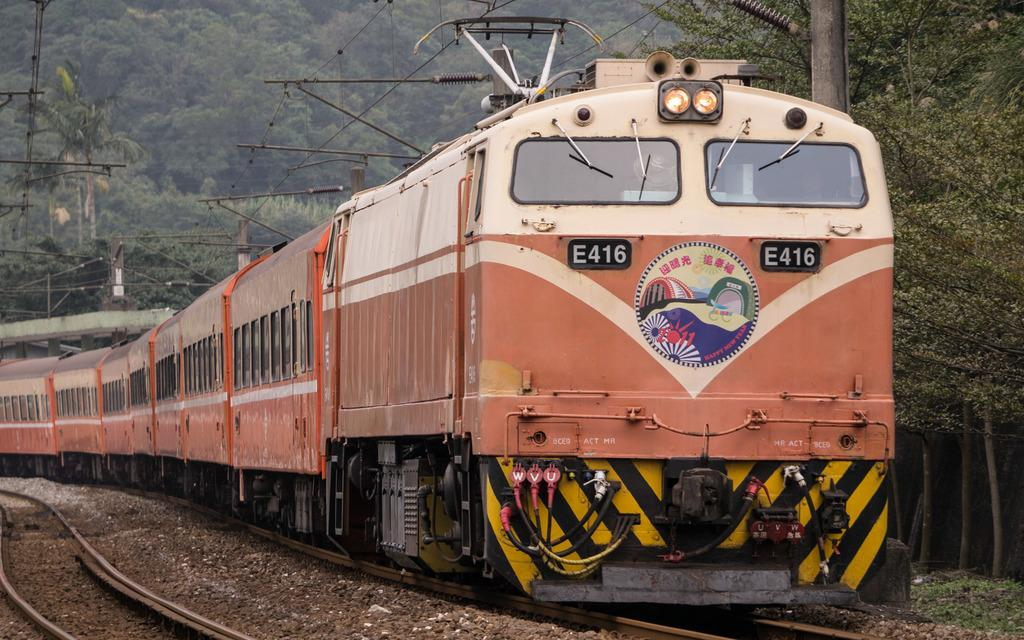<image>
Share a concise interpretation of the image provided. An E416 train going along the track through a forest 